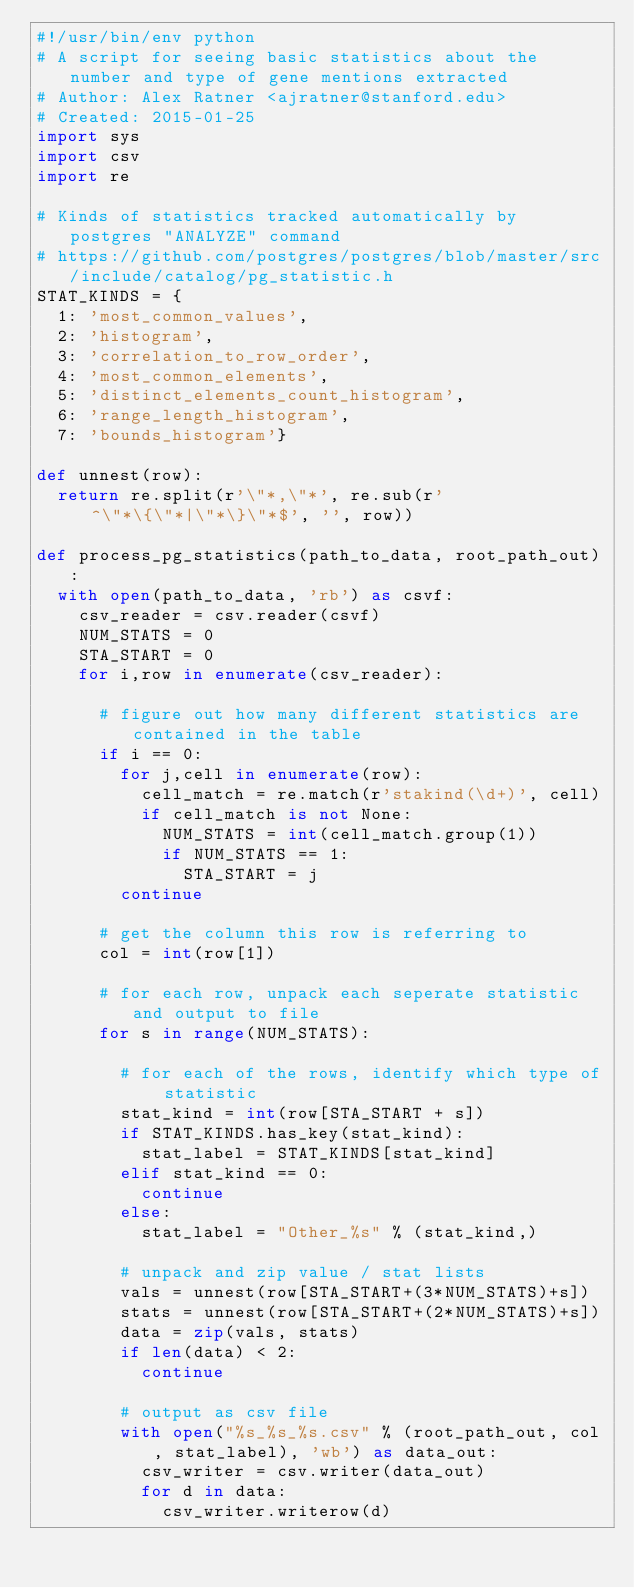Convert code to text. <code><loc_0><loc_0><loc_500><loc_500><_Python_>#!/usr/bin/env python
# A script for seeing basic statistics about the number and type of gene mentions extracted
# Author: Alex Ratner <ajratner@stanford.edu>
# Created: 2015-01-25
import sys
import csv
import re

# Kinds of statistics tracked automatically by postgres "ANALYZE" command
# https://github.com/postgres/postgres/blob/master/src/include/catalog/pg_statistic.h
STAT_KINDS = {
  1: 'most_common_values',
  2: 'histogram',
  3: 'correlation_to_row_order',
  4: 'most_common_elements',
  5: 'distinct_elements_count_histogram',
  6: 'range_length_histogram',
  7: 'bounds_histogram'}

def unnest(row):
  return re.split(r'\"*,\"*', re.sub(r'^\"*\{\"*|\"*\}\"*$', '', row))

def process_pg_statistics(path_to_data, root_path_out):
  with open(path_to_data, 'rb') as csvf:
    csv_reader = csv.reader(csvf)
    NUM_STATS = 0
    STA_START = 0
    for i,row in enumerate(csv_reader):
      
      # figure out how many different statistics are contained in the table
      if i == 0:
        for j,cell in enumerate(row):
          cell_match = re.match(r'stakind(\d+)', cell)
          if cell_match is not None:
            NUM_STATS = int(cell_match.group(1))
            if NUM_STATS == 1:
              STA_START = j
        continue

      # get the column this row is referring to
      col = int(row[1])

      # for each row, unpack each seperate statistic and output to file
      for s in range(NUM_STATS):

        # for each of the rows, identify which type of statistic
        stat_kind = int(row[STA_START + s])
        if STAT_KINDS.has_key(stat_kind):
          stat_label = STAT_KINDS[stat_kind]
        elif stat_kind == 0:
          continue
        else:
          stat_label = "Other_%s" % (stat_kind,)

        # unpack and zip value / stat lists
        vals = unnest(row[STA_START+(3*NUM_STATS)+s])
        stats = unnest(row[STA_START+(2*NUM_STATS)+s])
        data = zip(vals, stats)
        if len(data) < 2:
          continue

        # output as csv file
        with open("%s_%s_%s.csv" % (root_path_out, col, stat_label), 'wb') as data_out:
          csv_writer = csv.writer(data_out)
          for d in data:
            csv_writer.writerow(d)
</code> 